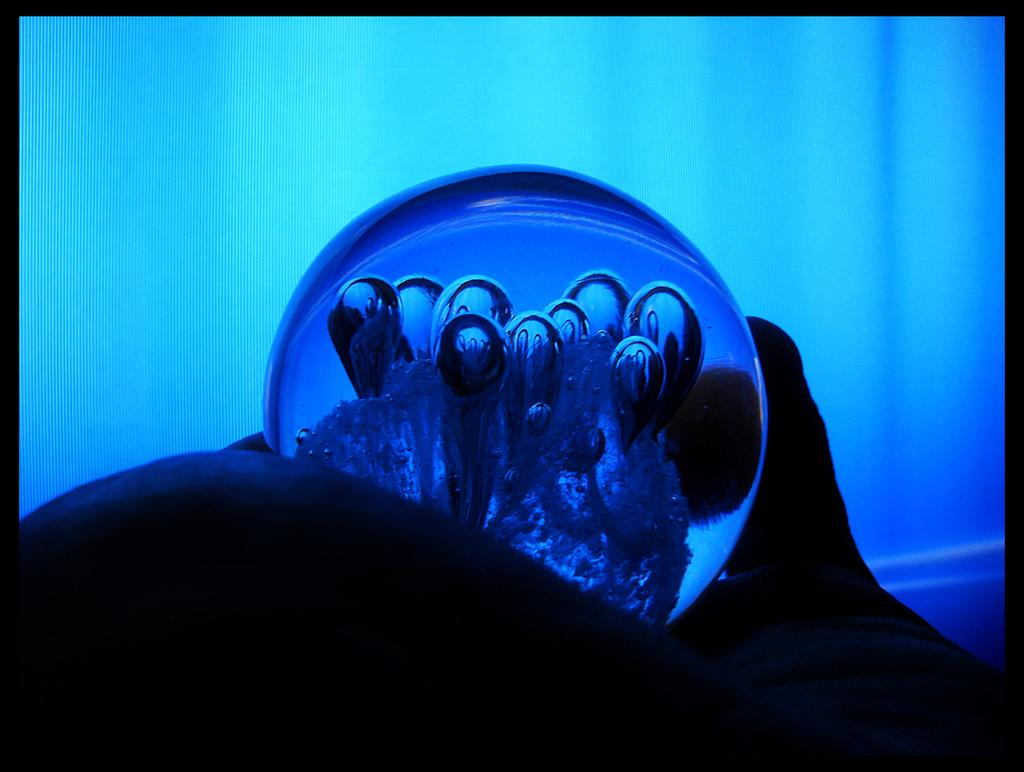What is the main subject of the image? There is an object in the center of the image. What type of chalk is being used to draw during the feast in the image? There is no chalk or feast present in the image; it only features an object in the center. 